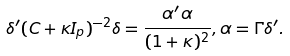<formula> <loc_0><loc_0><loc_500><loc_500>\delta ^ { \prime } ( C + \kappa I _ { p } ) ^ { - 2 } \delta = \frac { \alpha ^ { \prime } \alpha } { ( 1 + \kappa ) ^ { 2 } } , \alpha = \Gamma \delta ^ { \prime } .</formula> 